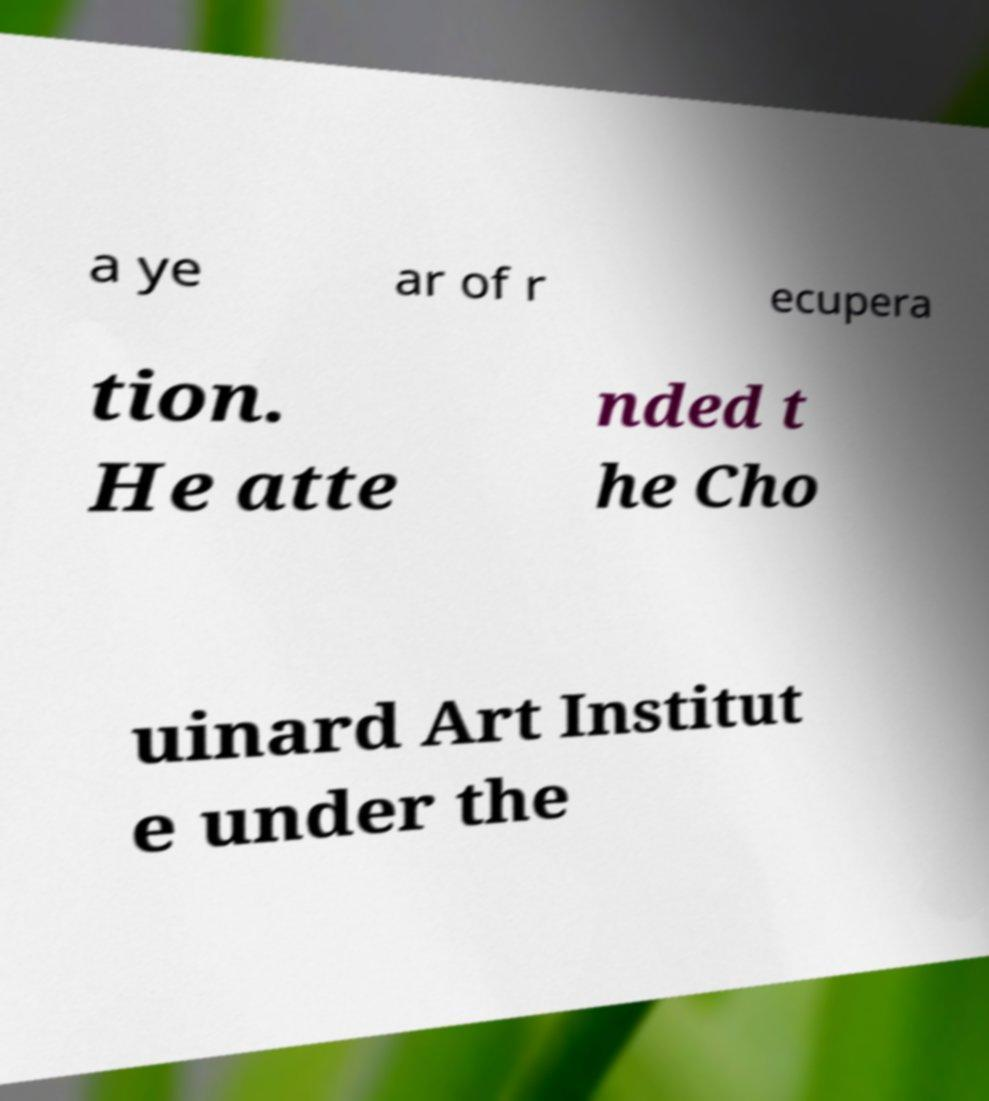I need the written content from this picture converted into text. Can you do that? a ye ar of r ecupera tion. He atte nded t he Cho uinard Art Institut e under the 